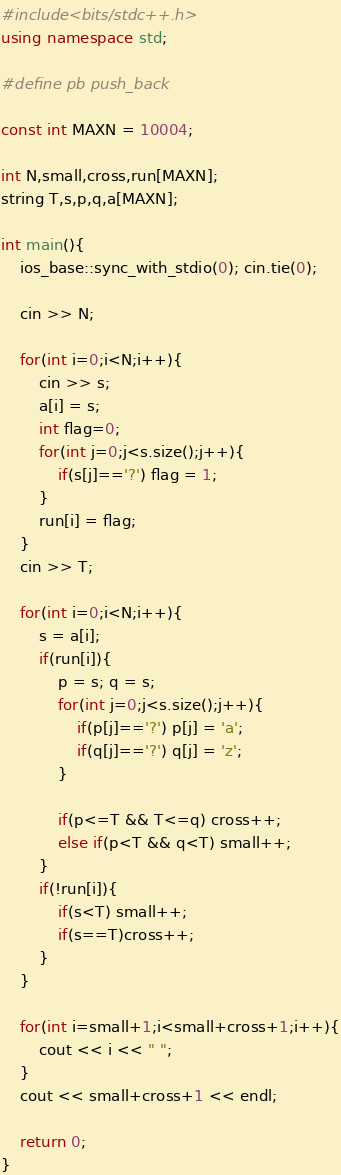<code> <loc_0><loc_0><loc_500><loc_500><_C++_>#include<bits/stdc++.h>
using namespace std;

#define pb push_back

const int MAXN = 10004;

int N,small,cross,run[MAXN];
string T,s,p,q,a[MAXN];

int main(){
    ios_base::sync_with_stdio(0); cin.tie(0);

    cin >> N;

    for(int i=0;i<N;i++){
        cin >> s;
        a[i] = s;
        int flag=0;
        for(int j=0;j<s.size();j++){
            if(s[j]=='?') flag = 1;
        }
        run[i] = flag;
    }
    cin >> T;

    for(int i=0;i<N;i++){
        s = a[i];
        if(run[i]){
            p = s; q = s;
            for(int j=0;j<s.size();j++){
                if(p[j]=='?') p[j] = 'a';
                if(q[j]=='?') q[j] = 'z';
            }

            if(p<=T && T<=q) cross++;
            else if(p<T && q<T) small++;
        }
        if(!run[i]){
            if(s<T) small++;
            if(s==T)cross++;
        }
    }

    for(int i=small+1;i<small+cross+1;i++){
        cout << i << " ";
    }
    cout << small+cross+1 << endl;

    return 0;
}
</code> 